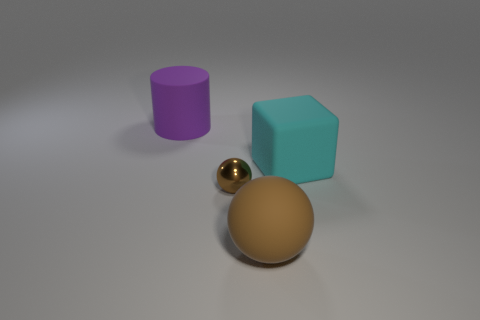Does the tiny thing have the same color as the rubber ball?
Your response must be concise. Yes. There is a big matte thing behind the object on the right side of the big brown sphere; what shape is it?
Your answer should be compact. Cylinder. There is a brown object that is made of the same material as the cylinder; what shape is it?
Offer a terse response. Sphere. Does the ball to the left of the brown rubber thing have the same size as the object that is in front of the tiny ball?
Provide a short and direct response. No. There is a large thing left of the metallic sphere; what is its shape?
Your answer should be compact. Cylinder. What is the color of the metallic ball?
Offer a very short reply. Brown. Do the brown metallic sphere and the ball that is to the right of the small brown sphere have the same size?
Keep it short and to the point. No. What number of matte things are either large objects or big gray cubes?
Give a very brief answer. 3. Are there any other things that have the same material as the purple thing?
Offer a terse response. Yes. There is a small ball; is it the same color as the rubber thing in front of the large cyan block?
Your answer should be very brief. Yes. 